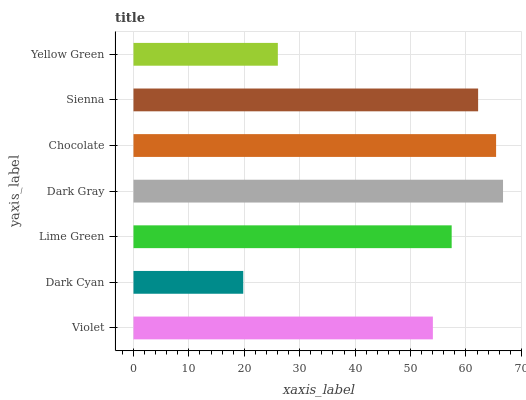Is Dark Cyan the minimum?
Answer yes or no. Yes. Is Dark Gray the maximum?
Answer yes or no. Yes. Is Lime Green the minimum?
Answer yes or no. No. Is Lime Green the maximum?
Answer yes or no. No. Is Lime Green greater than Dark Cyan?
Answer yes or no. Yes. Is Dark Cyan less than Lime Green?
Answer yes or no. Yes. Is Dark Cyan greater than Lime Green?
Answer yes or no. No. Is Lime Green less than Dark Cyan?
Answer yes or no. No. Is Lime Green the high median?
Answer yes or no. Yes. Is Lime Green the low median?
Answer yes or no. Yes. Is Chocolate the high median?
Answer yes or no. No. Is Chocolate the low median?
Answer yes or no. No. 